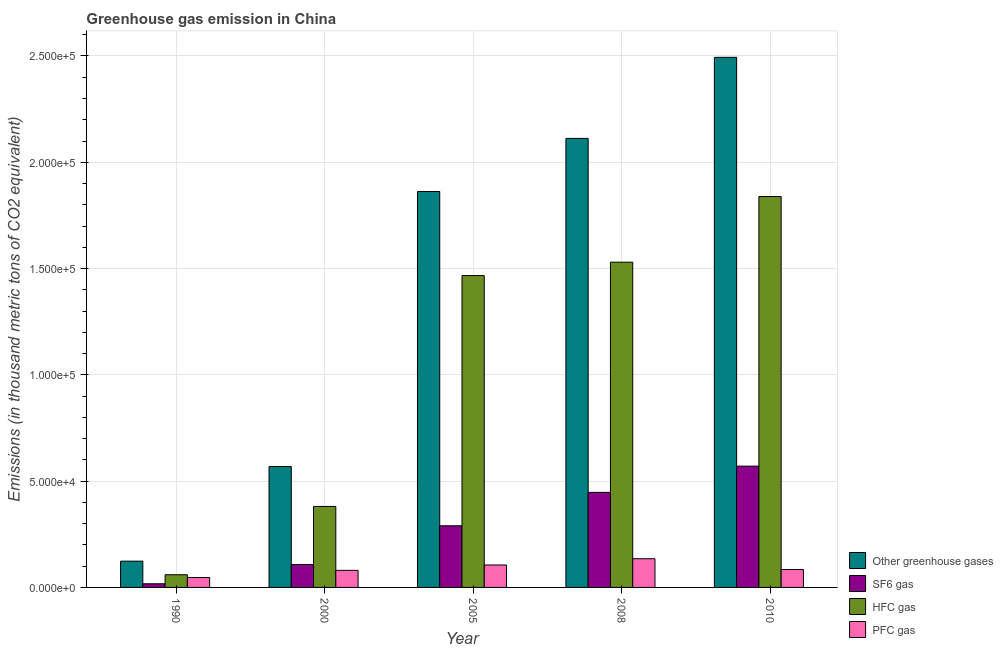Are the number of bars per tick equal to the number of legend labels?
Provide a succinct answer. Yes. How many bars are there on the 1st tick from the left?
Give a very brief answer. 4. How many bars are there on the 1st tick from the right?
Provide a succinct answer. 4. In how many cases, is the number of bars for a given year not equal to the number of legend labels?
Offer a terse response. 0. What is the emission of sf6 gas in 1990?
Your response must be concise. 1708.6. Across all years, what is the maximum emission of hfc gas?
Give a very brief answer. 1.84e+05. Across all years, what is the minimum emission of greenhouse gases?
Your response must be concise. 1.24e+04. In which year was the emission of hfc gas maximum?
Keep it short and to the point. 2010. In which year was the emission of hfc gas minimum?
Your response must be concise. 1990. What is the total emission of pfc gas in the graph?
Offer a very short reply. 4.52e+04. What is the difference between the emission of pfc gas in 2005 and that in 2008?
Your response must be concise. -2937.8. What is the difference between the emission of sf6 gas in 2005 and the emission of pfc gas in 1990?
Ensure brevity in your answer.  2.73e+04. What is the average emission of sf6 gas per year?
Offer a very short reply. 2.86e+04. In how many years, is the emission of sf6 gas greater than 30000 thousand metric tons?
Your answer should be very brief. 2. What is the ratio of the emission of sf6 gas in 2000 to that in 2008?
Make the answer very short. 0.24. Is the emission of hfc gas in 2005 less than that in 2008?
Keep it short and to the point. Yes. What is the difference between the highest and the second highest emission of pfc gas?
Your response must be concise. 2937.8. What is the difference between the highest and the lowest emission of pfc gas?
Make the answer very short. 8826.1. In how many years, is the emission of greenhouse gases greater than the average emission of greenhouse gases taken over all years?
Offer a very short reply. 3. What does the 1st bar from the left in 1990 represents?
Ensure brevity in your answer.  Other greenhouse gases. What does the 2nd bar from the right in 2008 represents?
Provide a short and direct response. HFC gas. Is it the case that in every year, the sum of the emission of greenhouse gases and emission of sf6 gas is greater than the emission of hfc gas?
Your answer should be compact. Yes. How many bars are there?
Keep it short and to the point. 20. Are all the bars in the graph horizontal?
Provide a succinct answer. No. How many years are there in the graph?
Offer a terse response. 5. Does the graph contain grids?
Give a very brief answer. Yes. Where does the legend appear in the graph?
Your response must be concise. Bottom right. How many legend labels are there?
Your answer should be very brief. 4. What is the title of the graph?
Provide a short and direct response. Greenhouse gas emission in China. What is the label or title of the Y-axis?
Provide a short and direct response. Emissions (in thousand metric tons of CO2 equivalent). What is the Emissions (in thousand metric tons of CO2 equivalent) in Other greenhouse gases in 1990?
Your answer should be very brief. 1.24e+04. What is the Emissions (in thousand metric tons of CO2 equivalent) in SF6 gas in 1990?
Make the answer very short. 1708.6. What is the Emissions (in thousand metric tons of CO2 equivalent) of HFC gas in 1990?
Provide a short and direct response. 5970.1. What is the Emissions (in thousand metric tons of CO2 equivalent) in PFC gas in 1990?
Your answer should be very brief. 4674.5. What is the Emissions (in thousand metric tons of CO2 equivalent) of Other greenhouse gases in 2000?
Ensure brevity in your answer.  5.69e+04. What is the Emissions (in thousand metric tons of CO2 equivalent) in SF6 gas in 2000?
Your answer should be very brief. 1.08e+04. What is the Emissions (in thousand metric tons of CO2 equivalent) of HFC gas in 2000?
Make the answer very short. 3.81e+04. What is the Emissions (in thousand metric tons of CO2 equivalent) of PFC gas in 2000?
Provide a succinct answer. 8034.4. What is the Emissions (in thousand metric tons of CO2 equivalent) of Other greenhouse gases in 2005?
Offer a very short reply. 1.86e+05. What is the Emissions (in thousand metric tons of CO2 equivalent) in SF6 gas in 2005?
Ensure brevity in your answer.  2.90e+04. What is the Emissions (in thousand metric tons of CO2 equivalent) of HFC gas in 2005?
Make the answer very short. 1.47e+05. What is the Emissions (in thousand metric tons of CO2 equivalent) in PFC gas in 2005?
Offer a very short reply. 1.06e+04. What is the Emissions (in thousand metric tons of CO2 equivalent) of Other greenhouse gases in 2008?
Your response must be concise. 2.11e+05. What is the Emissions (in thousand metric tons of CO2 equivalent) in SF6 gas in 2008?
Your answer should be compact. 4.47e+04. What is the Emissions (in thousand metric tons of CO2 equivalent) of HFC gas in 2008?
Offer a very short reply. 1.53e+05. What is the Emissions (in thousand metric tons of CO2 equivalent) of PFC gas in 2008?
Keep it short and to the point. 1.35e+04. What is the Emissions (in thousand metric tons of CO2 equivalent) of Other greenhouse gases in 2010?
Provide a short and direct response. 2.49e+05. What is the Emissions (in thousand metric tons of CO2 equivalent) in SF6 gas in 2010?
Provide a short and direct response. 5.71e+04. What is the Emissions (in thousand metric tons of CO2 equivalent) of HFC gas in 2010?
Your answer should be very brief. 1.84e+05. What is the Emissions (in thousand metric tons of CO2 equivalent) of PFC gas in 2010?
Offer a terse response. 8438. Across all years, what is the maximum Emissions (in thousand metric tons of CO2 equivalent) of Other greenhouse gases?
Your answer should be compact. 2.49e+05. Across all years, what is the maximum Emissions (in thousand metric tons of CO2 equivalent) of SF6 gas?
Your answer should be very brief. 5.71e+04. Across all years, what is the maximum Emissions (in thousand metric tons of CO2 equivalent) of HFC gas?
Your answer should be very brief. 1.84e+05. Across all years, what is the maximum Emissions (in thousand metric tons of CO2 equivalent) in PFC gas?
Your answer should be very brief. 1.35e+04. Across all years, what is the minimum Emissions (in thousand metric tons of CO2 equivalent) of Other greenhouse gases?
Your answer should be compact. 1.24e+04. Across all years, what is the minimum Emissions (in thousand metric tons of CO2 equivalent) in SF6 gas?
Ensure brevity in your answer.  1708.6. Across all years, what is the minimum Emissions (in thousand metric tons of CO2 equivalent) in HFC gas?
Give a very brief answer. 5970.1. Across all years, what is the minimum Emissions (in thousand metric tons of CO2 equivalent) in PFC gas?
Provide a short and direct response. 4674.5. What is the total Emissions (in thousand metric tons of CO2 equivalent) of Other greenhouse gases in the graph?
Your response must be concise. 7.16e+05. What is the total Emissions (in thousand metric tons of CO2 equivalent) of SF6 gas in the graph?
Keep it short and to the point. 1.43e+05. What is the total Emissions (in thousand metric tons of CO2 equivalent) of HFC gas in the graph?
Offer a very short reply. 5.28e+05. What is the total Emissions (in thousand metric tons of CO2 equivalent) of PFC gas in the graph?
Give a very brief answer. 4.52e+04. What is the difference between the Emissions (in thousand metric tons of CO2 equivalent) of Other greenhouse gases in 1990 and that in 2000?
Your answer should be compact. -4.45e+04. What is the difference between the Emissions (in thousand metric tons of CO2 equivalent) in SF6 gas in 1990 and that in 2000?
Make the answer very short. -9045. What is the difference between the Emissions (in thousand metric tons of CO2 equivalent) in HFC gas in 1990 and that in 2000?
Your answer should be compact. -3.21e+04. What is the difference between the Emissions (in thousand metric tons of CO2 equivalent) of PFC gas in 1990 and that in 2000?
Provide a short and direct response. -3359.9. What is the difference between the Emissions (in thousand metric tons of CO2 equivalent) of Other greenhouse gases in 1990 and that in 2005?
Make the answer very short. -1.74e+05. What is the difference between the Emissions (in thousand metric tons of CO2 equivalent) in SF6 gas in 1990 and that in 2005?
Provide a short and direct response. -2.73e+04. What is the difference between the Emissions (in thousand metric tons of CO2 equivalent) in HFC gas in 1990 and that in 2005?
Provide a short and direct response. -1.41e+05. What is the difference between the Emissions (in thousand metric tons of CO2 equivalent) in PFC gas in 1990 and that in 2005?
Make the answer very short. -5888.3. What is the difference between the Emissions (in thousand metric tons of CO2 equivalent) of Other greenhouse gases in 1990 and that in 2008?
Provide a succinct answer. -1.99e+05. What is the difference between the Emissions (in thousand metric tons of CO2 equivalent) in SF6 gas in 1990 and that in 2008?
Your answer should be very brief. -4.30e+04. What is the difference between the Emissions (in thousand metric tons of CO2 equivalent) in HFC gas in 1990 and that in 2008?
Provide a succinct answer. -1.47e+05. What is the difference between the Emissions (in thousand metric tons of CO2 equivalent) in PFC gas in 1990 and that in 2008?
Make the answer very short. -8826.1. What is the difference between the Emissions (in thousand metric tons of CO2 equivalent) in Other greenhouse gases in 1990 and that in 2010?
Make the answer very short. -2.37e+05. What is the difference between the Emissions (in thousand metric tons of CO2 equivalent) of SF6 gas in 1990 and that in 2010?
Your answer should be very brief. -5.53e+04. What is the difference between the Emissions (in thousand metric tons of CO2 equivalent) of HFC gas in 1990 and that in 2010?
Offer a very short reply. -1.78e+05. What is the difference between the Emissions (in thousand metric tons of CO2 equivalent) in PFC gas in 1990 and that in 2010?
Your answer should be compact. -3763.5. What is the difference between the Emissions (in thousand metric tons of CO2 equivalent) in Other greenhouse gases in 2000 and that in 2005?
Offer a terse response. -1.29e+05. What is the difference between the Emissions (in thousand metric tons of CO2 equivalent) in SF6 gas in 2000 and that in 2005?
Ensure brevity in your answer.  -1.82e+04. What is the difference between the Emissions (in thousand metric tons of CO2 equivalent) of HFC gas in 2000 and that in 2005?
Your response must be concise. -1.09e+05. What is the difference between the Emissions (in thousand metric tons of CO2 equivalent) in PFC gas in 2000 and that in 2005?
Your answer should be compact. -2528.4. What is the difference between the Emissions (in thousand metric tons of CO2 equivalent) in Other greenhouse gases in 2000 and that in 2008?
Ensure brevity in your answer.  -1.54e+05. What is the difference between the Emissions (in thousand metric tons of CO2 equivalent) of SF6 gas in 2000 and that in 2008?
Give a very brief answer. -3.40e+04. What is the difference between the Emissions (in thousand metric tons of CO2 equivalent) in HFC gas in 2000 and that in 2008?
Keep it short and to the point. -1.15e+05. What is the difference between the Emissions (in thousand metric tons of CO2 equivalent) in PFC gas in 2000 and that in 2008?
Offer a terse response. -5466.2. What is the difference between the Emissions (in thousand metric tons of CO2 equivalent) in Other greenhouse gases in 2000 and that in 2010?
Keep it short and to the point. -1.92e+05. What is the difference between the Emissions (in thousand metric tons of CO2 equivalent) in SF6 gas in 2000 and that in 2010?
Give a very brief answer. -4.63e+04. What is the difference between the Emissions (in thousand metric tons of CO2 equivalent) in HFC gas in 2000 and that in 2010?
Offer a very short reply. -1.46e+05. What is the difference between the Emissions (in thousand metric tons of CO2 equivalent) in PFC gas in 2000 and that in 2010?
Offer a terse response. -403.6. What is the difference between the Emissions (in thousand metric tons of CO2 equivalent) of Other greenhouse gases in 2005 and that in 2008?
Offer a terse response. -2.50e+04. What is the difference between the Emissions (in thousand metric tons of CO2 equivalent) in SF6 gas in 2005 and that in 2008?
Ensure brevity in your answer.  -1.57e+04. What is the difference between the Emissions (in thousand metric tons of CO2 equivalent) of HFC gas in 2005 and that in 2008?
Your answer should be compact. -6309. What is the difference between the Emissions (in thousand metric tons of CO2 equivalent) of PFC gas in 2005 and that in 2008?
Make the answer very short. -2937.8. What is the difference between the Emissions (in thousand metric tons of CO2 equivalent) in Other greenhouse gases in 2005 and that in 2010?
Give a very brief answer. -6.31e+04. What is the difference between the Emissions (in thousand metric tons of CO2 equivalent) of SF6 gas in 2005 and that in 2010?
Your answer should be very brief. -2.81e+04. What is the difference between the Emissions (in thousand metric tons of CO2 equivalent) of HFC gas in 2005 and that in 2010?
Offer a very short reply. -3.72e+04. What is the difference between the Emissions (in thousand metric tons of CO2 equivalent) in PFC gas in 2005 and that in 2010?
Provide a short and direct response. 2124.8. What is the difference between the Emissions (in thousand metric tons of CO2 equivalent) in Other greenhouse gases in 2008 and that in 2010?
Offer a very short reply. -3.81e+04. What is the difference between the Emissions (in thousand metric tons of CO2 equivalent) in SF6 gas in 2008 and that in 2010?
Keep it short and to the point. -1.23e+04. What is the difference between the Emissions (in thousand metric tons of CO2 equivalent) in HFC gas in 2008 and that in 2010?
Offer a very short reply. -3.09e+04. What is the difference between the Emissions (in thousand metric tons of CO2 equivalent) of PFC gas in 2008 and that in 2010?
Give a very brief answer. 5062.6. What is the difference between the Emissions (in thousand metric tons of CO2 equivalent) in Other greenhouse gases in 1990 and the Emissions (in thousand metric tons of CO2 equivalent) in SF6 gas in 2000?
Your answer should be compact. 1599.6. What is the difference between the Emissions (in thousand metric tons of CO2 equivalent) of Other greenhouse gases in 1990 and the Emissions (in thousand metric tons of CO2 equivalent) of HFC gas in 2000?
Provide a short and direct response. -2.57e+04. What is the difference between the Emissions (in thousand metric tons of CO2 equivalent) in Other greenhouse gases in 1990 and the Emissions (in thousand metric tons of CO2 equivalent) in PFC gas in 2000?
Ensure brevity in your answer.  4318.8. What is the difference between the Emissions (in thousand metric tons of CO2 equivalent) in SF6 gas in 1990 and the Emissions (in thousand metric tons of CO2 equivalent) in HFC gas in 2000?
Provide a succinct answer. -3.64e+04. What is the difference between the Emissions (in thousand metric tons of CO2 equivalent) in SF6 gas in 1990 and the Emissions (in thousand metric tons of CO2 equivalent) in PFC gas in 2000?
Your answer should be compact. -6325.8. What is the difference between the Emissions (in thousand metric tons of CO2 equivalent) of HFC gas in 1990 and the Emissions (in thousand metric tons of CO2 equivalent) of PFC gas in 2000?
Offer a terse response. -2064.3. What is the difference between the Emissions (in thousand metric tons of CO2 equivalent) in Other greenhouse gases in 1990 and the Emissions (in thousand metric tons of CO2 equivalent) in SF6 gas in 2005?
Your response must be concise. -1.66e+04. What is the difference between the Emissions (in thousand metric tons of CO2 equivalent) of Other greenhouse gases in 1990 and the Emissions (in thousand metric tons of CO2 equivalent) of HFC gas in 2005?
Ensure brevity in your answer.  -1.34e+05. What is the difference between the Emissions (in thousand metric tons of CO2 equivalent) of Other greenhouse gases in 1990 and the Emissions (in thousand metric tons of CO2 equivalent) of PFC gas in 2005?
Keep it short and to the point. 1790.4. What is the difference between the Emissions (in thousand metric tons of CO2 equivalent) in SF6 gas in 1990 and the Emissions (in thousand metric tons of CO2 equivalent) in HFC gas in 2005?
Make the answer very short. -1.45e+05. What is the difference between the Emissions (in thousand metric tons of CO2 equivalent) of SF6 gas in 1990 and the Emissions (in thousand metric tons of CO2 equivalent) of PFC gas in 2005?
Ensure brevity in your answer.  -8854.2. What is the difference between the Emissions (in thousand metric tons of CO2 equivalent) of HFC gas in 1990 and the Emissions (in thousand metric tons of CO2 equivalent) of PFC gas in 2005?
Provide a succinct answer. -4592.7. What is the difference between the Emissions (in thousand metric tons of CO2 equivalent) in Other greenhouse gases in 1990 and the Emissions (in thousand metric tons of CO2 equivalent) in SF6 gas in 2008?
Your response must be concise. -3.24e+04. What is the difference between the Emissions (in thousand metric tons of CO2 equivalent) in Other greenhouse gases in 1990 and the Emissions (in thousand metric tons of CO2 equivalent) in HFC gas in 2008?
Ensure brevity in your answer.  -1.41e+05. What is the difference between the Emissions (in thousand metric tons of CO2 equivalent) in Other greenhouse gases in 1990 and the Emissions (in thousand metric tons of CO2 equivalent) in PFC gas in 2008?
Your answer should be very brief. -1147.4. What is the difference between the Emissions (in thousand metric tons of CO2 equivalent) of SF6 gas in 1990 and the Emissions (in thousand metric tons of CO2 equivalent) of HFC gas in 2008?
Give a very brief answer. -1.51e+05. What is the difference between the Emissions (in thousand metric tons of CO2 equivalent) in SF6 gas in 1990 and the Emissions (in thousand metric tons of CO2 equivalent) in PFC gas in 2008?
Your answer should be compact. -1.18e+04. What is the difference between the Emissions (in thousand metric tons of CO2 equivalent) in HFC gas in 1990 and the Emissions (in thousand metric tons of CO2 equivalent) in PFC gas in 2008?
Give a very brief answer. -7530.5. What is the difference between the Emissions (in thousand metric tons of CO2 equivalent) of Other greenhouse gases in 1990 and the Emissions (in thousand metric tons of CO2 equivalent) of SF6 gas in 2010?
Offer a very short reply. -4.47e+04. What is the difference between the Emissions (in thousand metric tons of CO2 equivalent) in Other greenhouse gases in 1990 and the Emissions (in thousand metric tons of CO2 equivalent) in HFC gas in 2010?
Give a very brief answer. -1.72e+05. What is the difference between the Emissions (in thousand metric tons of CO2 equivalent) of Other greenhouse gases in 1990 and the Emissions (in thousand metric tons of CO2 equivalent) of PFC gas in 2010?
Provide a short and direct response. 3915.2. What is the difference between the Emissions (in thousand metric tons of CO2 equivalent) in SF6 gas in 1990 and the Emissions (in thousand metric tons of CO2 equivalent) in HFC gas in 2010?
Your answer should be compact. -1.82e+05. What is the difference between the Emissions (in thousand metric tons of CO2 equivalent) of SF6 gas in 1990 and the Emissions (in thousand metric tons of CO2 equivalent) of PFC gas in 2010?
Ensure brevity in your answer.  -6729.4. What is the difference between the Emissions (in thousand metric tons of CO2 equivalent) of HFC gas in 1990 and the Emissions (in thousand metric tons of CO2 equivalent) of PFC gas in 2010?
Your answer should be very brief. -2467.9. What is the difference between the Emissions (in thousand metric tons of CO2 equivalent) in Other greenhouse gases in 2000 and the Emissions (in thousand metric tons of CO2 equivalent) in SF6 gas in 2005?
Keep it short and to the point. 2.79e+04. What is the difference between the Emissions (in thousand metric tons of CO2 equivalent) of Other greenhouse gases in 2000 and the Emissions (in thousand metric tons of CO2 equivalent) of HFC gas in 2005?
Ensure brevity in your answer.  -8.98e+04. What is the difference between the Emissions (in thousand metric tons of CO2 equivalent) of Other greenhouse gases in 2000 and the Emissions (in thousand metric tons of CO2 equivalent) of PFC gas in 2005?
Provide a short and direct response. 4.63e+04. What is the difference between the Emissions (in thousand metric tons of CO2 equivalent) in SF6 gas in 2000 and the Emissions (in thousand metric tons of CO2 equivalent) in HFC gas in 2005?
Offer a very short reply. -1.36e+05. What is the difference between the Emissions (in thousand metric tons of CO2 equivalent) of SF6 gas in 2000 and the Emissions (in thousand metric tons of CO2 equivalent) of PFC gas in 2005?
Provide a short and direct response. 190.8. What is the difference between the Emissions (in thousand metric tons of CO2 equivalent) in HFC gas in 2000 and the Emissions (in thousand metric tons of CO2 equivalent) in PFC gas in 2005?
Your response must be concise. 2.75e+04. What is the difference between the Emissions (in thousand metric tons of CO2 equivalent) in Other greenhouse gases in 2000 and the Emissions (in thousand metric tons of CO2 equivalent) in SF6 gas in 2008?
Ensure brevity in your answer.  1.22e+04. What is the difference between the Emissions (in thousand metric tons of CO2 equivalent) in Other greenhouse gases in 2000 and the Emissions (in thousand metric tons of CO2 equivalent) in HFC gas in 2008?
Offer a terse response. -9.61e+04. What is the difference between the Emissions (in thousand metric tons of CO2 equivalent) of Other greenhouse gases in 2000 and the Emissions (in thousand metric tons of CO2 equivalent) of PFC gas in 2008?
Offer a very short reply. 4.34e+04. What is the difference between the Emissions (in thousand metric tons of CO2 equivalent) in SF6 gas in 2000 and the Emissions (in thousand metric tons of CO2 equivalent) in HFC gas in 2008?
Provide a short and direct response. -1.42e+05. What is the difference between the Emissions (in thousand metric tons of CO2 equivalent) of SF6 gas in 2000 and the Emissions (in thousand metric tons of CO2 equivalent) of PFC gas in 2008?
Make the answer very short. -2747. What is the difference between the Emissions (in thousand metric tons of CO2 equivalent) of HFC gas in 2000 and the Emissions (in thousand metric tons of CO2 equivalent) of PFC gas in 2008?
Provide a short and direct response. 2.46e+04. What is the difference between the Emissions (in thousand metric tons of CO2 equivalent) in Other greenhouse gases in 2000 and the Emissions (in thousand metric tons of CO2 equivalent) in SF6 gas in 2010?
Offer a terse response. -172. What is the difference between the Emissions (in thousand metric tons of CO2 equivalent) in Other greenhouse gases in 2000 and the Emissions (in thousand metric tons of CO2 equivalent) in HFC gas in 2010?
Offer a terse response. -1.27e+05. What is the difference between the Emissions (in thousand metric tons of CO2 equivalent) in Other greenhouse gases in 2000 and the Emissions (in thousand metric tons of CO2 equivalent) in PFC gas in 2010?
Your answer should be very brief. 4.84e+04. What is the difference between the Emissions (in thousand metric tons of CO2 equivalent) in SF6 gas in 2000 and the Emissions (in thousand metric tons of CO2 equivalent) in HFC gas in 2010?
Make the answer very short. -1.73e+05. What is the difference between the Emissions (in thousand metric tons of CO2 equivalent) in SF6 gas in 2000 and the Emissions (in thousand metric tons of CO2 equivalent) in PFC gas in 2010?
Offer a terse response. 2315.6. What is the difference between the Emissions (in thousand metric tons of CO2 equivalent) of HFC gas in 2000 and the Emissions (in thousand metric tons of CO2 equivalent) of PFC gas in 2010?
Ensure brevity in your answer.  2.97e+04. What is the difference between the Emissions (in thousand metric tons of CO2 equivalent) in Other greenhouse gases in 2005 and the Emissions (in thousand metric tons of CO2 equivalent) in SF6 gas in 2008?
Offer a very short reply. 1.42e+05. What is the difference between the Emissions (in thousand metric tons of CO2 equivalent) in Other greenhouse gases in 2005 and the Emissions (in thousand metric tons of CO2 equivalent) in HFC gas in 2008?
Your response must be concise. 3.33e+04. What is the difference between the Emissions (in thousand metric tons of CO2 equivalent) in Other greenhouse gases in 2005 and the Emissions (in thousand metric tons of CO2 equivalent) in PFC gas in 2008?
Keep it short and to the point. 1.73e+05. What is the difference between the Emissions (in thousand metric tons of CO2 equivalent) in SF6 gas in 2005 and the Emissions (in thousand metric tons of CO2 equivalent) in HFC gas in 2008?
Offer a very short reply. -1.24e+05. What is the difference between the Emissions (in thousand metric tons of CO2 equivalent) of SF6 gas in 2005 and the Emissions (in thousand metric tons of CO2 equivalent) of PFC gas in 2008?
Keep it short and to the point. 1.55e+04. What is the difference between the Emissions (in thousand metric tons of CO2 equivalent) of HFC gas in 2005 and the Emissions (in thousand metric tons of CO2 equivalent) of PFC gas in 2008?
Ensure brevity in your answer.  1.33e+05. What is the difference between the Emissions (in thousand metric tons of CO2 equivalent) in Other greenhouse gases in 2005 and the Emissions (in thousand metric tons of CO2 equivalent) in SF6 gas in 2010?
Your response must be concise. 1.29e+05. What is the difference between the Emissions (in thousand metric tons of CO2 equivalent) of Other greenhouse gases in 2005 and the Emissions (in thousand metric tons of CO2 equivalent) of HFC gas in 2010?
Your answer should be very brief. 2383.5. What is the difference between the Emissions (in thousand metric tons of CO2 equivalent) in Other greenhouse gases in 2005 and the Emissions (in thousand metric tons of CO2 equivalent) in PFC gas in 2010?
Provide a succinct answer. 1.78e+05. What is the difference between the Emissions (in thousand metric tons of CO2 equivalent) in SF6 gas in 2005 and the Emissions (in thousand metric tons of CO2 equivalent) in HFC gas in 2010?
Your answer should be very brief. -1.55e+05. What is the difference between the Emissions (in thousand metric tons of CO2 equivalent) of SF6 gas in 2005 and the Emissions (in thousand metric tons of CO2 equivalent) of PFC gas in 2010?
Provide a succinct answer. 2.06e+04. What is the difference between the Emissions (in thousand metric tons of CO2 equivalent) of HFC gas in 2005 and the Emissions (in thousand metric tons of CO2 equivalent) of PFC gas in 2010?
Offer a terse response. 1.38e+05. What is the difference between the Emissions (in thousand metric tons of CO2 equivalent) of Other greenhouse gases in 2008 and the Emissions (in thousand metric tons of CO2 equivalent) of SF6 gas in 2010?
Your answer should be very brief. 1.54e+05. What is the difference between the Emissions (in thousand metric tons of CO2 equivalent) in Other greenhouse gases in 2008 and the Emissions (in thousand metric tons of CO2 equivalent) in HFC gas in 2010?
Make the answer very short. 2.74e+04. What is the difference between the Emissions (in thousand metric tons of CO2 equivalent) in Other greenhouse gases in 2008 and the Emissions (in thousand metric tons of CO2 equivalent) in PFC gas in 2010?
Keep it short and to the point. 2.03e+05. What is the difference between the Emissions (in thousand metric tons of CO2 equivalent) of SF6 gas in 2008 and the Emissions (in thousand metric tons of CO2 equivalent) of HFC gas in 2010?
Offer a very short reply. -1.39e+05. What is the difference between the Emissions (in thousand metric tons of CO2 equivalent) in SF6 gas in 2008 and the Emissions (in thousand metric tons of CO2 equivalent) in PFC gas in 2010?
Ensure brevity in your answer.  3.63e+04. What is the difference between the Emissions (in thousand metric tons of CO2 equivalent) of HFC gas in 2008 and the Emissions (in thousand metric tons of CO2 equivalent) of PFC gas in 2010?
Make the answer very short. 1.45e+05. What is the average Emissions (in thousand metric tons of CO2 equivalent) of Other greenhouse gases per year?
Your answer should be compact. 1.43e+05. What is the average Emissions (in thousand metric tons of CO2 equivalent) in SF6 gas per year?
Your answer should be compact. 2.86e+04. What is the average Emissions (in thousand metric tons of CO2 equivalent) of HFC gas per year?
Your answer should be compact. 1.06e+05. What is the average Emissions (in thousand metric tons of CO2 equivalent) in PFC gas per year?
Offer a very short reply. 9042.06. In the year 1990, what is the difference between the Emissions (in thousand metric tons of CO2 equivalent) of Other greenhouse gases and Emissions (in thousand metric tons of CO2 equivalent) of SF6 gas?
Your response must be concise. 1.06e+04. In the year 1990, what is the difference between the Emissions (in thousand metric tons of CO2 equivalent) of Other greenhouse gases and Emissions (in thousand metric tons of CO2 equivalent) of HFC gas?
Offer a very short reply. 6383.1. In the year 1990, what is the difference between the Emissions (in thousand metric tons of CO2 equivalent) of Other greenhouse gases and Emissions (in thousand metric tons of CO2 equivalent) of PFC gas?
Provide a succinct answer. 7678.7. In the year 1990, what is the difference between the Emissions (in thousand metric tons of CO2 equivalent) of SF6 gas and Emissions (in thousand metric tons of CO2 equivalent) of HFC gas?
Ensure brevity in your answer.  -4261.5. In the year 1990, what is the difference between the Emissions (in thousand metric tons of CO2 equivalent) of SF6 gas and Emissions (in thousand metric tons of CO2 equivalent) of PFC gas?
Your answer should be compact. -2965.9. In the year 1990, what is the difference between the Emissions (in thousand metric tons of CO2 equivalent) in HFC gas and Emissions (in thousand metric tons of CO2 equivalent) in PFC gas?
Give a very brief answer. 1295.6. In the year 2000, what is the difference between the Emissions (in thousand metric tons of CO2 equivalent) of Other greenhouse gases and Emissions (in thousand metric tons of CO2 equivalent) of SF6 gas?
Keep it short and to the point. 4.61e+04. In the year 2000, what is the difference between the Emissions (in thousand metric tons of CO2 equivalent) of Other greenhouse gases and Emissions (in thousand metric tons of CO2 equivalent) of HFC gas?
Keep it short and to the point. 1.88e+04. In the year 2000, what is the difference between the Emissions (in thousand metric tons of CO2 equivalent) of Other greenhouse gases and Emissions (in thousand metric tons of CO2 equivalent) of PFC gas?
Provide a short and direct response. 4.88e+04. In the year 2000, what is the difference between the Emissions (in thousand metric tons of CO2 equivalent) in SF6 gas and Emissions (in thousand metric tons of CO2 equivalent) in HFC gas?
Provide a succinct answer. -2.73e+04. In the year 2000, what is the difference between the Emissions (in thousand metric tons of CO2 equivalent) in SF6 gas and Emissions (in thousand metric tons of CO2 equivalent) in PFC gas?
Provide a succinct answer. 2719.2. In the year 2000, what is the difference between the Emissions (in thousand metric tons of CO2 equivalent) of HFC gas and Emissions (in thousand metric tons of CO2 equivalent) of PFC gas?
Give a very brief answer. 3.01e+04. In the year 2005, what is the difference between the Emissions (in thousand metric tons of CO2 equivalent) of Other greenhouse gases and Emissions (in thousand metric tons of CO2 equivalent) of SF6 gas?
Your answer should be compact. 1.57e+05. In the year 2005, what is the difference between the Emissions (in thousand metric tons of CO2 equivalent) in Other greenhouse gases and Emissions (in thousand metric tons of CO2 equivalent) in HFC gas?
Offer a terse response. 3.96e+04. In the year 2005, what is the difference between the Emissions (in thousand metric tons of CO2 equivalent) in Other greenhouse gases and Emissions (in thousand metric tons of CO2 equivalent) in PFC gas?
Give a very brief answer. 1.76e+05. In the year 2005, what is the difference between the Emissions (in thousand metric tons of CO2 equivalent) of SF6 gas and Emissions (in thousand metric tons of CO2 equivalent) of HFC gas?
Your response must be concise. -1.18e+05. In the year 2005, what is the difference between the Emissions (in thousand metric tons of CO2 equivalent) in SF6 gas and Emissions (in thousand metric tons of CO2 equivalent) in PFC gas?
Your answer should be very brief. 1.84e+04. In the year 2005, what is the difference between the Emissions (in thousand metric tons of CO2 equivalent) of HFC gas and Emissions (in thousand metric tons of CO2 equivalent) of PFC gas?
Offer a terse response. 1.36e+05. In the year 2008, what is the difference between the Emissions (in thousand metric tons of CO2 equivalent) of Other greenhouse gases and Emissions (in thousand metric tons of CO2 equivalent) of SF6 gas?
Ensure brevity in your answer.  1.66e+05. In the year 2008, what is the difference between the Emissions (in thousand metric tons of CO2 equivalent) of Other greenhouse gases and Emissions (in thousand metric tons of CO2 equivalent) of HFC gas?
Give a very brief answer. 5.82e+04. In the year 2008, what is the difference between the Emissions (in thousand metric tons of CO2 equivalent) of Other greenhouse gases and Emissions (in thousand metric tons of CO2 equivalent) of PFC gas?
Keep it short and to the point. 1.98e+05. In the year 2008, what is the difference between the Emissions (in thousand metric tons of CO2 equivalent) in SF6 gas and Emissions (in thousand metric tons of CO2 equivalent) in HFC gas?
Offer a terse response. -1.08e+05. In the year 2008, what is the difference between the Emissions (in thousand metric tons of CO2 equivalent) of SF6 gas and Emissions (in thousand metric tons of CO2 equivalent) of PFC gas?
Offer a very short reply. 3.12e+04. In the year 2008, what is the difference between the Emissions (in thousand metric tons of CO2 equivalent) of HFC gas and Emissions (in thousand metric tons of CO2 equivalent) of PFC gas?
Your response must be concise. 1.39e+05. In the year 2010, what is the difference between the Emissions (in thousand metric tons of CO2 equivalent) of Other greenhouse gases and Emissions (in thousand metric tons of CO2 equivalent) of SF6 gas?
Make the answer very short. 1.92e+05. In the year 2010, what is the difference between the Emissions (in thousand metric tons of CO2 equivalent) in Other greenhouse gases and Emissions (in thousand metric tons of CO2 equivalent) in HFC gas?
Your answer should be compact. 6.55e+04. In the year 2010, what is the difference between the Emissions (in thousand metric tons of CO2 equivalent) in Other greenhouse gases and Emissions (in thousand metric tons of CO2 equivalent) in PFC gas?
Ensure brevity in your answer.  2.41e+05. In the year 2010, what is the difference between the Emissions (in thousand metric tons of CO2 equivalent) in SF6 gas and Emissions (in thousand metric tons of CO2 equivalent) in HFC gas?
Provide a succinct answer. -1.27e+05. In the year 2010, what is the difference between the Emissions (in thousand metric tons of CO2 equivalent) in SF6 gas and Emissions (in thousand metric tons of CO2 equivalent) in PFC gas?
Make the answer very short. 4.86e+04. In the year 2010, what is the difference between the Emissions (in thousand metric tons of CO2 equivalent) of HFC gas and Emissions (in thousand metric tons of CO2 equivalent) of PFC gas?
Offer a very short reply. 1.75e+05. What is the ratio of the Emissions (in thousand metric tons of CO2 equivalent) in Other greenhouse gases in 1990 to that in 2000?
Give a very brief answer. 0.22. What is the ratio of the Emissions (in thousand metric tons of CO2 equivalent) in SF6 gas in 1990 to that in 2000?
Your response must be concise. 0.16. What is the ratio of the Emissions (in thousand metric tons of CO2 equivalent) of HFC gas in 1990 to that in 2000?
Make the answer very short. 0.16. What is the ratio of the Emissions (in thousand metric tons of CO2 equivalent) in PFC gas in 1990 to that in 2000?
Ensure brevity in your answer.  0.58. What is the ratio of the Emissions (in thousand metric tons of CO2 equivalent) in Other greenhouse gases in 1990 to that in 2005?
Keep it short and to the point. 0.07. What is the ratio of the Emissions (in thousand metric tons of CO2 equivalent) of SF6 gas in 1990 to that in 2005?
Give a very brief answer. 0.06. What is the ratio of the Emissions (in thousand metric tons of CO2 equivalent) in HFC gas in 1990 to that in 2005?
Your answer should be compact. 0.04. What is the ratio of the Emissions (in thousand metric tons of CO2 equivalent) in PFC gas in 1990 to that in 2005?
Give a very brief answer. 0.44. What is the ratio of the Emissions (in thousand metric tons of CO2 equivalent) in Other greenhouse gases in 1990 to that in 2008?
Make the answer very short. 0.06. What is the ratio of the Emissions (in thousand metric tons of CO2 equivalent) in SF6 gas in 1990 to that in 2008?
Give a very brief answer. 0.04. What is the ratio of the Emissions (in thousand metric tons of CO2 equivalent) of HFC gas in 1990 to that in 2008?
Offer a terse response. 0.04. What is the ratio of the Emissions (in thousand metric tons of CO2 equivalent) of PFC gas in 1990 to that in 2008?
Make the answer very short. 0.35. What is the ratio of the Emissions (in thousand metric tons of CO2 equivalent) in Other greenhouse gases in 1990 to that in 2010?
Make the answer very short. 0.05. What is the ratio of the Emissions (in thousand metric tons of CO2 equivalent) in SF6 gas in 1990 to that in 2010?
Ensure brevity in your answer.  0.03. What is the ratio of the Emissions (in thousand metric tons of CO2 equivalent) in HFC gas in 1990 to that in 2010?
Offer a very short reply. 0.03. What is the ratio of the Emissions (in thousand metric tons of CO2 equivalent) of PFC gas in 1990 to that in 2010?
Ensure brevity in your answer.  0.55. What is the ratio of the Emissions (in thousand metric tons of CO2 equivalent) of Other greenhouse gases in 2000 to that in 2005?
Your answer should be compact. 0.31. What is the ratio of the Emissions (in thousand metric tons of CO2 equivalent) of SF6 gas in 2000 to that in 2005?
Offer a terse response. 0.37. What is the ratio of the Emissions (in thousand metric tons of CO2 equivalent) of HFC gas in 2000 to that in 2005?
Offer a very short reply. 0.26. What is the ratio of the Emissions (in thousand metric tons of CO2 equivalent) of PFC gas in 2000 to that in 2005?
Provide a succinct answer. 0.76. What is the ratio of the Emissions (in thousand metric tons of CO2 equivalent) in Other greenhouse gases in 2000 to that in 2008?
Your answer should be compact. 0.27. What is the ratio of the Emissions (in thousand metric tons of CO2 equivalent) of SF6 gas in 2000 to that in 2008?
Offer a very short reply. 0.24. What is the ratio of the Emissions (in thousand metric tons of CO2 equivalent) of HFC gas in 2000 to that in 2008?
Make the answer very short. 0.25. What is the ratio of the Emissions (in thousand metric tons of CO2 equivalent) of PFC gas in 2000 to that in 2008?
Provide a succinct answer. 0.6. What is the ratio of the Emissions (in thousand metric tons of CO2 equivalent) of Other greenhouse gases in 2000 to that in 2010?
Offer a terse response. 0.23. What is the ratio of the Emissions (in thousand metric tons of CO2 equivalent) of SF6 gas in 2000 to that in 2010?
Provide a succinct answer. 0.19. What is the ratio of the Emissions (in thousand metric tons of CO2 equivalent) of HFC gas in 2000 to that in 2010?
Ensure brevity in your answer.  0.21. What is the ratio of the Emissions (in thousand metric tons of CO2 equivalent) in PFC gas in 2000 to that in 2010?
Give a very brief answer. 0.95. What is the ratio of the Emissions (in thousand metric tons of CO2 equivalent) of Other greenhouse gases in 2005 to that in 2008?
Make the answer very short. 0.88. What is the ratio of the Emissions (in thousand metric tons of CO2 equivalent) of SF6 gas in 2005 to that in 2008?
Your answer should be very brief. 0.65. What is the ratio of the Emissions (in thousand metric tons of CO2 equivalent) of HFC gas in 2005 to that in 2008?
Your answer should be compact. 0.96. What is the ratio of the Emissions (in thousand metric tons of CO2 equivalent) in PFC gas in 2005 to that in 2008?
Your response must be concise. 0.78. What is the ratio of the Emissions (in thousand metric tons of CO2 equivalent) in Other greenhouse gases in 2005 to that in 2010?
Ensure brevity in your answer.  0.75. What is the ratio of the Emissions (in thousand metric tons of CO2 equivalent) in SF6 gas in 2005 to that in 2010?
Your answer should be compact. 0.51. What is the ratio of the Emissions (in thousand metric tons of CO2 equivalent) in HFC gas in 2005 to that in 2010?
Provide a succinct answer. 0.8. What is the ratio of the Emissions (in thousand metric tons of CO2 equivalent) in PFC gas in 2005 to that in 2010?
Your answer should be compact. 1.25. What is the ratio of the Emissions (in thousand metric tons of CO2 equivalent) in Other greenhouse gases in 2008 to that in 2010?
Offer a terse response. 0.85. What is the ratio of the Emissions (in thousand metric tons of CO2 equivalent) of SF6 gas in 2008 to that in 2010?
Ensure brevity in your answer.  0.78. What is the ratio of the Emissions (in thousand metric tons of CO2 equivalent) in HFC gas in 2008 to that in 2010?
Your answer should be compact. 0.83. What is the ratio of the Emissions (in thousand metric tons of CO2 equivalent) in PFC gas in 2008 to that in 2010?
Keep it short and to the point. 1.6. What is the difference between the highest and the second highest Emissions (in thousand metric tons of CO2 equivalent) in Other greenhouse gases?
Ensure brevity in your answer.  3.81e+04. What is the difference between the highest and the second highest Emissions (in thousand metric tons of CO2 equivalent) in SF6 gas?
Make the answer very short. 1.23e+04. What is the difference between the highest and the second highest Emissions (in thousand metric tons of CO2 equivalent) in HFC gas?
Provide a succinct answer. 3.09e+04. What is the difference between the highest and the second highest Emissions (in thousand metric tons of CO2 equivalent) of PFC gas?
Your answer should be compact. 2937.8. What is the difference between the highest and the lowest Emissions (in thousand metric tons of CO2 equivalent) in Other greenhouse gases?
Provide a succinct answer. 2.37e+05. What is the difference between the highest and the lowest Emissions (in thousand metric tons of CO2 equivalent) of SF6 gas?
Make the answer very short. 5.53e+04. What is the difference between the highest and the lowest Emissions (in thousand metric tons of CO2 equivalent) of HFC gas?
Give a very brief answer. 1.78e+05. What is the difference between the highest and the lowest Emissions (in thousand metric tons of CO2 equivalent) in PFC gas?
Your answer should be compact. 8826.1. 